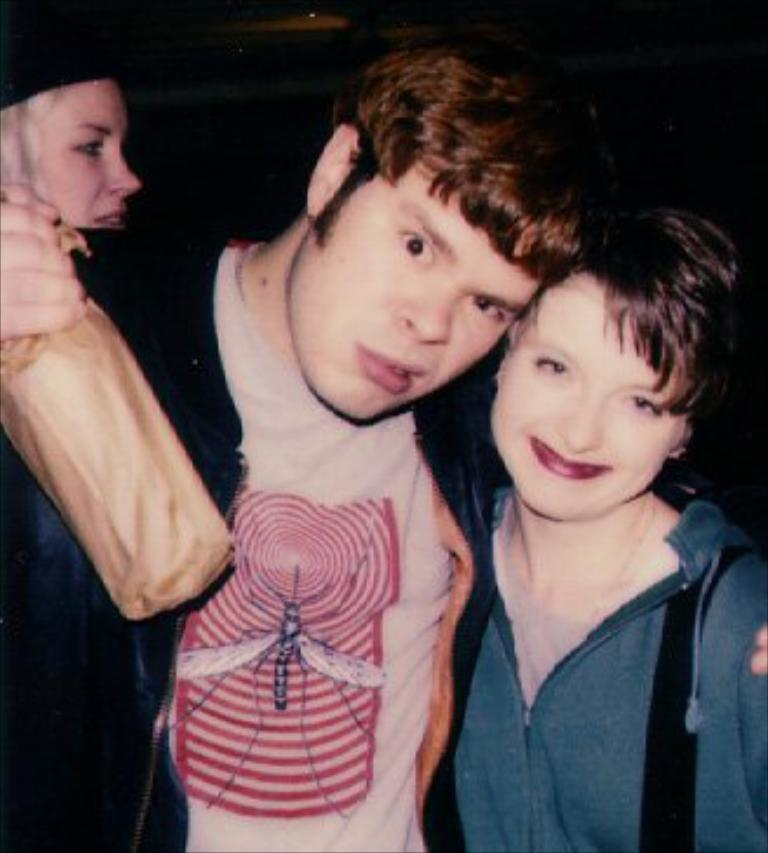What is happening in the image? There are people standing in the image. Can you describe what one of the people is holding? There is a person holding a cover in his hand. What can be observed about the lighting in the image? The background of the image is dark. What is the person's opinion about the pencil in the image? There is no pencil present in the image, so it is not possible to determine the person's opinion about a pencil. 